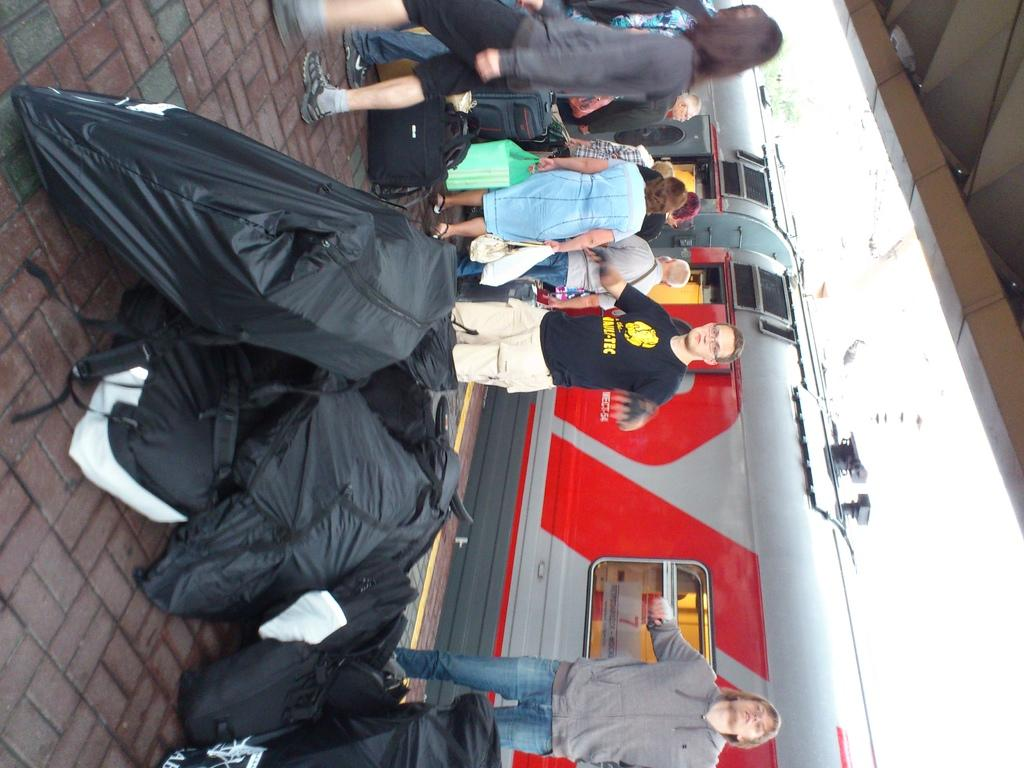What mode of transportation can be seen on the right side of the image? There is a train on the right side of the image. What are the people near the train doing? The provided facts do not specify what the people are doing near the train. Can you describe the train in the image? The facts only mention that there is a train on the right side of the image, but no specific details about the train are given. How many balls are being thrown in the air by the people near the train? There is no mention of balls or people throwing balls in the image. What type of waste can be seen near the train in the image? There is no mention of waste in the image. 